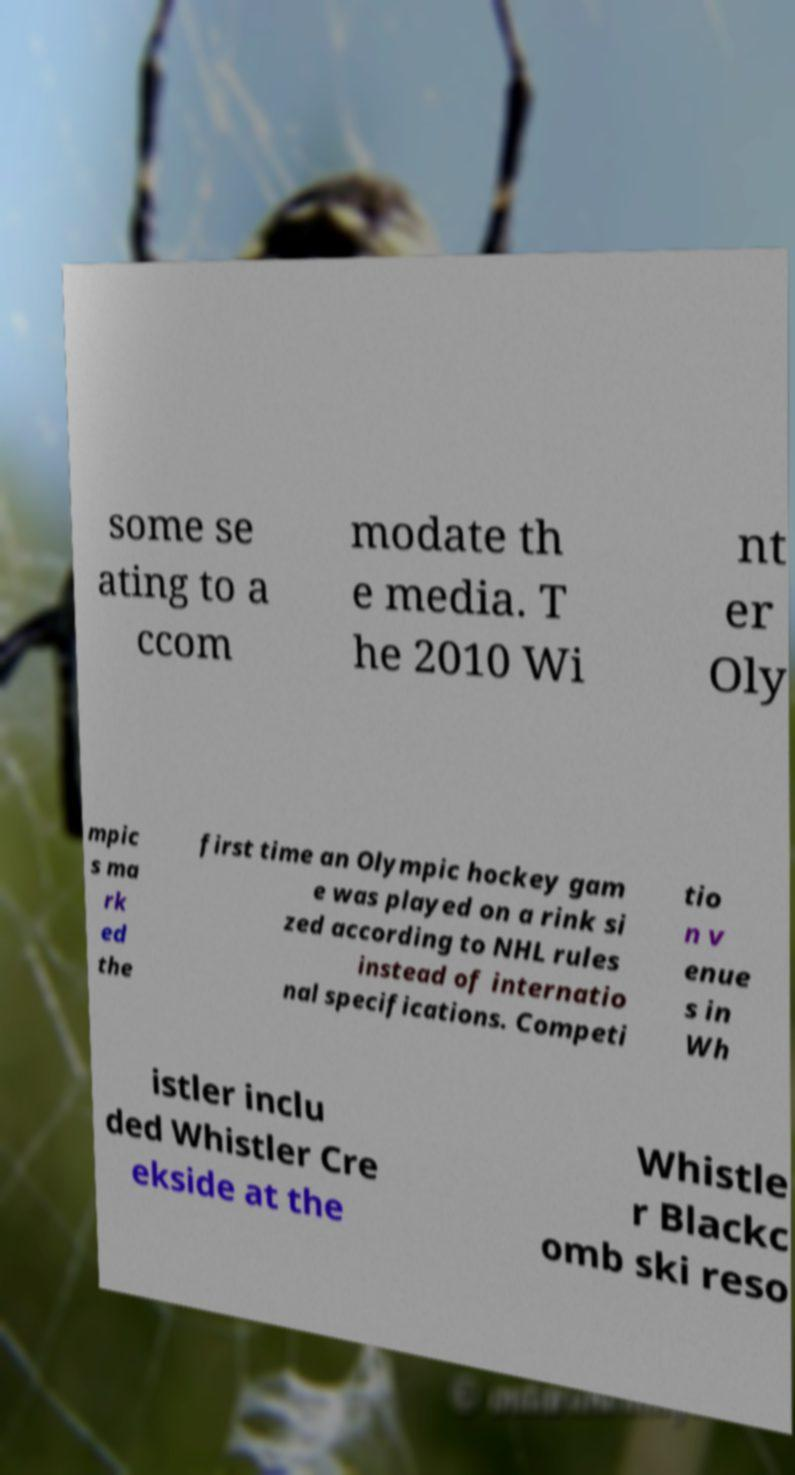What messages or text are displayed in this image? I need them in a readable, typed format. some se ating to a ccom modate th e media. T he 2010 Wi nt er Oly mpic s ma rk ed the first time an Olympic hockey gam e was played on a rink si zed according to NHL rules instead of internatio nal specifications. Competi tio n v enue s in Wh istler inclu ded Whistler Cre ekside at the Whistle r Blackc omb ski reso 